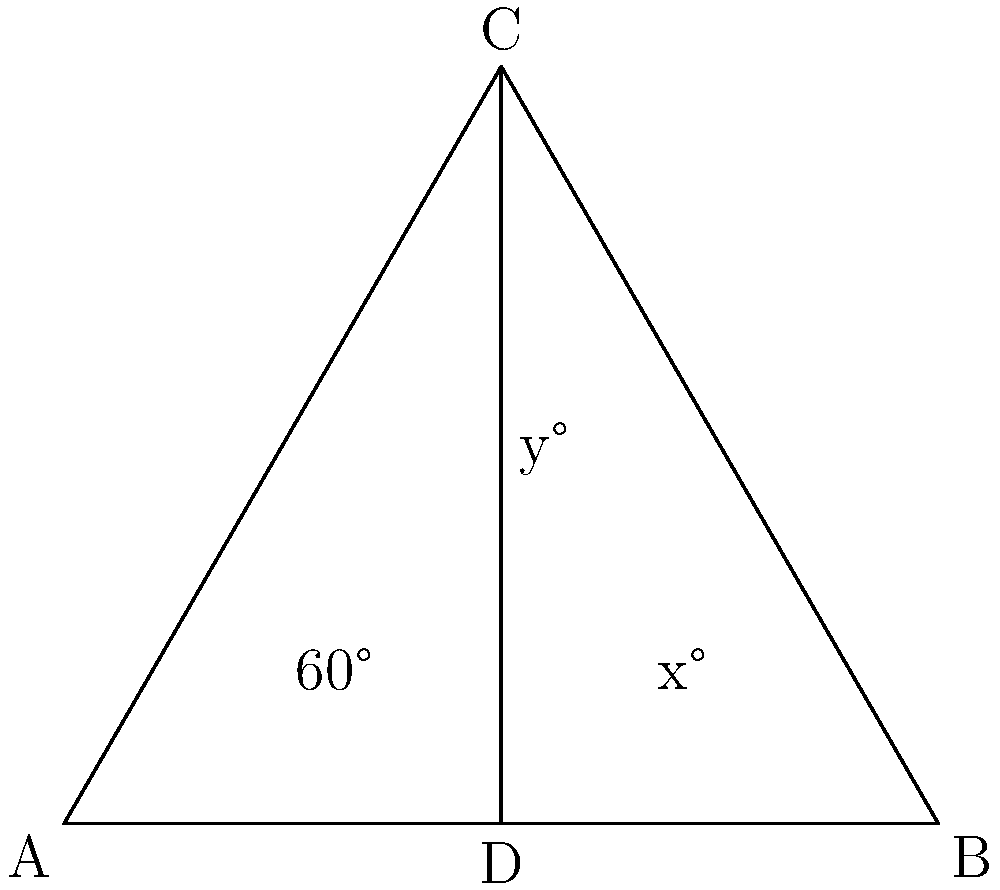In an animal sanctuary, safety barriers are being installed to create separate enclosures. The barriers intersect to form the triangle ABC shown above. If angle CAB is 60°, and CD bisects angle ACB, determine the value of x + y. Let's approach this step-by-step:

1) In triangle ABC, we're given that angle CAB is 60°.

2) CD bisects angle ACB. This means that angle ACD = angle BCD = y°.

3) In a triangle, the sum of all angles is 180°. So in triangle ABC:
   $60° + x° + 2y° = 180°$

4) In triangle ACD:
   - We know angle CAD is 60°
   - Angle ACD is y°
   - The sum of angles in a triangle is 180°
   So, $60° + y° + (90° - x/2) = 180°$

5) From step 4, we can derive:
   $150° + y° = x/2 + 180°$
   $y° = x/2 + 30°$

6) Substituting this into the equation from step 3:
   $60° + x° + 2(x/2 + 30°) = 180°$
   $60° + x° + x° + 60° = 180°$
   $2x° + 120° = 180°$
   $2x° = 60°$
   $x° = 30°$

7) Now we can find y:
   $y° = 30°/2 + 30° = 45°$

8) Therefore, x + y = 30° + 45° = 75°
Answer: 75° 